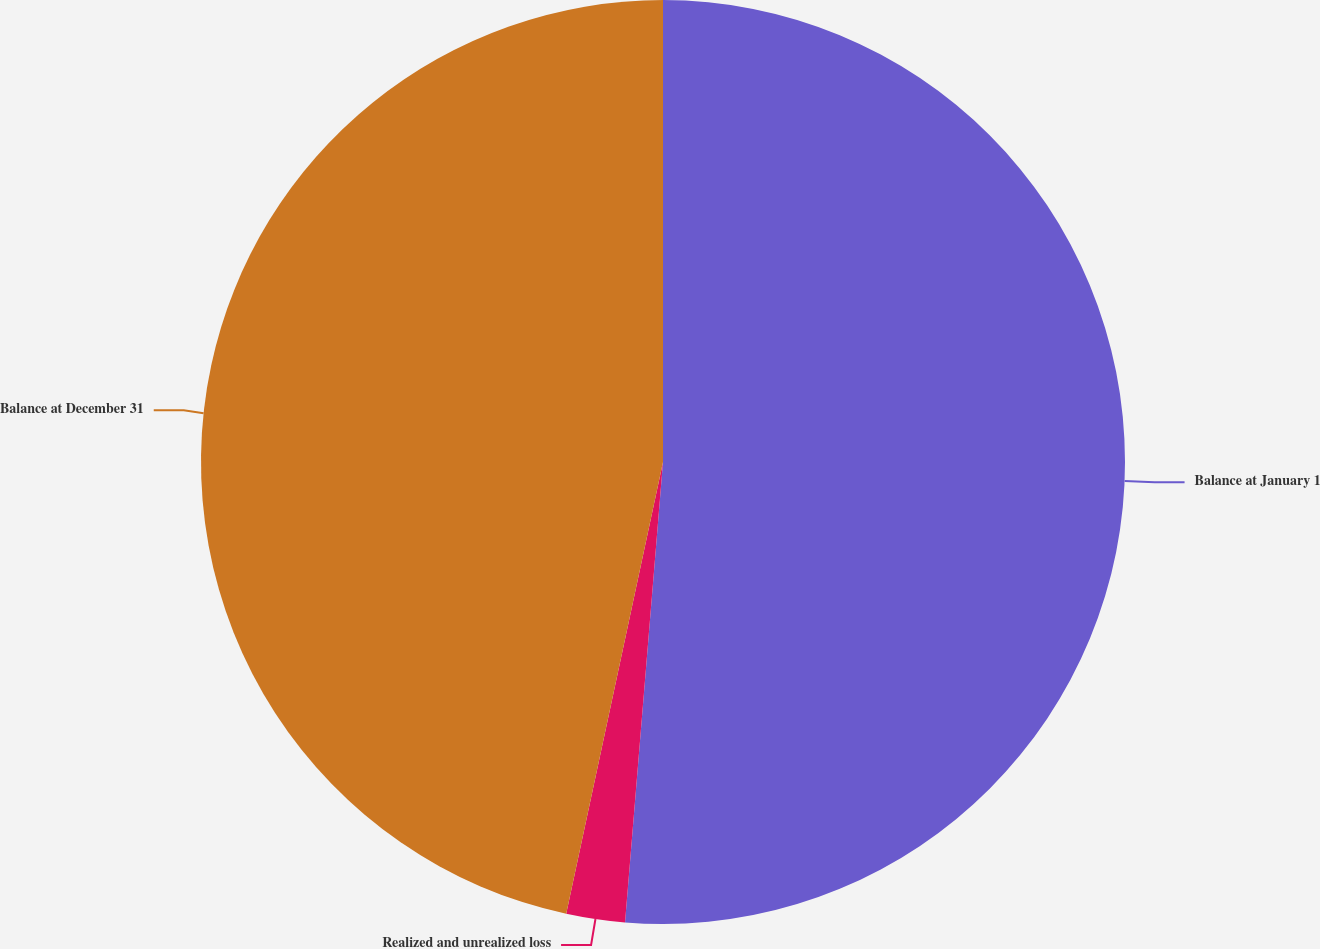Convert chart. <chart><loc_0><loc_0><loc_500><loc_500><pie_chart><fcel>Balance at January 1<fcel>Realized and unrealized loss<fcel>Balance at December 31<nl><fcel>51.31%<fcel>2.05%<fcel>46.64%<nl></chart> 